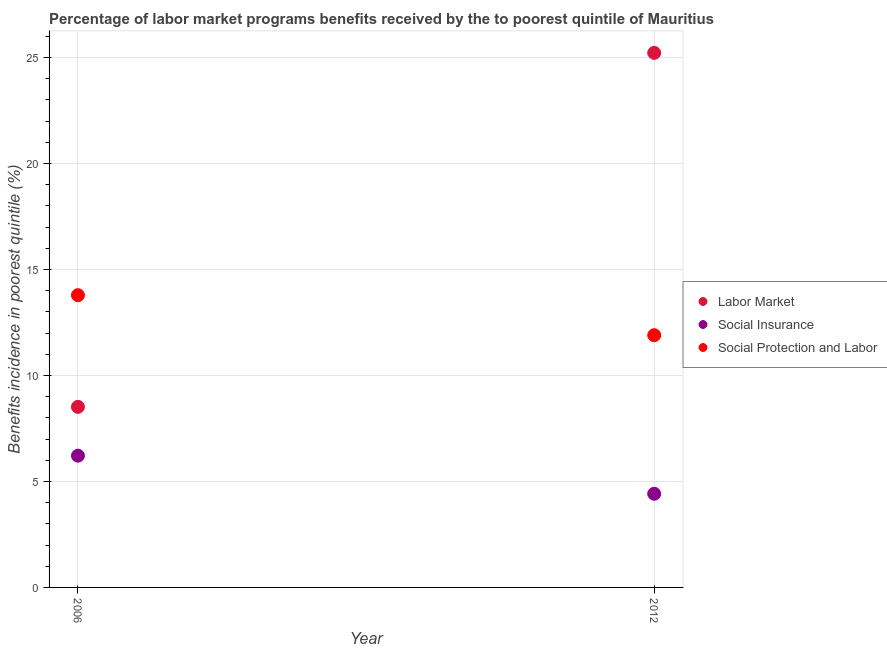What is the percentage of benefits received due to labor market programs in 2006?
Your response must be concise. 8.52. Across all years, what is the maximum percentage of benefits received due to labor market programs?
Ensure brevity in your answer.  25.22. Across all years, what is the minimum percentage of benefits received due to labor market programs?
Ensure brevity in your answer.  8.52. In which year was the percentage of benefits received due to social insurance programs maximum?
Keep it short and to the point. 2006. What is the total percentage of benefits received due to social insurance programs in the graph?
Keep it short and to the point. 10.63. What is the difference between the percentage of benefits received due to social insurance programs in 2006 and that in 2012?
Give a very brief answer. 1.8. What is the difference between the percentage of benefits received due to social protection programs in 2006 and the percentage of benefits received due to social insurance programs in 2012?
Offer a terse response. 9.37. What is the average percentage of benefits received due to social insurance programs per year?
Offer a very short reply. 5.32. In the year 2006, what is the difference between the percentage of benefits received due to social insurance programs and percentage of benefits received due to social protection programs?
Your answer should be very brief. -7.57. What is the ratio of the percentage of benefits received due to social protection programs in 2006 to that in 2012?
Offer a terse response. 1.16. In how many years, is the percentage of benefits received due to social protection programs greater than the average percentage of benefits received due to social protection programs taken over all years?
Provide a short and direct response. 1. Are the values on the major ticks of Y-axis written in scientific E-notation?
Keep it short and to the point. No. Does the graph contain any zero values?
Your answer should be compact. No. Does the graph contain grids?
Offer a very short reply. Yes. How many legend labels are there?
Keep it short and to the point. 3. How are the legend labels stacked?
Provide a short and direct response. Vertical. What is the title of the graph?
Offer a very short reply. Percentage of labor market programs benefits received by the to poorest quintile of Mauritius. What is the label or title of the X-axis?
Provide a short and direct response. Year. What is the label or title of the Y-axis?
Make the answer very short. Benefits incidence in poorest quintile (%). What is the Benefits incidence in poorest quintile (%) in Labor Market in 2006?
Your answer should be compact. 8.52. What is the Benefits incidence in poorest quintile (%) of Social Insurance in 2006?
Keep it short and to the point. 6.22. What is the Benefits incidence in poorest quintile (%) in Social Protection and Labor in 2006?
Provide a short and direct response. 13.79. What is the Benefits incidence in poorest quintile (%) of Labor Market in 2012?
Provide a succinct answer. 25.22. What is the Benefits incidence in poorest quintile (%) of Social Insurance in 2012?
Give a very brief answer. 4.42. What is the Benefits incidence in poorest quintile (%) in Social Protection and Labor in 2012?
Offer a terse response. 11.9. Across all years, what is the maximum Benefits incidence in poorest quintile (%) in Labor Market?
Provide a succinct answer. 25.22. Across all years, what is the maximum Benefits incidence in poorest quintile (%) in Social Insurance?
Keep it short and to the point. 6.22. Across all years, what is the maximum Benefits incidence in poorest quintile (%) of Social Protection and Labor?
Your response must be concise. 13.79. Across all years, what is the minimum Benefits incidence in poorest quintile (%) of Labor Market?
Provide a short and direct response. 8.52. Across all years, what is the minimum Benefits incidence in poorest quintile (%) of Social Insurance?
Ensure brevity in your answer.  4.42. Across all years, what is the minimum Benefits incidence in poorest quintile (%) of Social Protection and Labor?
Your answer should be compact. 11.9. What is the total Benefits incidence in poorest quintile (%) in Labor Market in the graph?
Make the answer very short. 33.73. What is the total Benefits incidence in poorest quintile (%) in Social Insurance in the graph?
Keep it short and to the point. 10.63. What is the total Benefits incidence in poorest quintile (%) of Social Protection and Labor in the graph?
Keep it short and to the point. 25.68. What is the difference between the Benefits incidence in poorest quintile (%) in Labor Market in 2006 and that in 2012?
Keep it short and to the point. -16.7. What is the difference between the Benefits incidence in poorest quintile (%) of Social Insurance in 2006 and that in 2012?
Your answer should be very brief. 1.8. What is the difference between the Benefits incidence in poorest quintile (%) in Social Protection and Labor in 2006 and that in 2012?
Your answer should be compact. 1.89. What is the difference between the Benefits incidence in poorest quintile (%) in Labor Market in 2006 and the Benefits incidence in poorest quintile (%) in Social Insurance in 2012?
Your response must be concise. 4.1. What is the difference between the Benefits incidence in poorest quintile (%) in Labor Market in 2006 and the Benefits incidence in poorest quintile (%) in Social Protection and Labor in 2012?
Keep it short and to the point. -3.38. What is the difference between the Benefits incidence in poorest quintile (%) in Social Insurance in 2006 and the Benefits incidence in poorest quintile (%) in Social Protection and Labor in 2012?
Provide a short and direct response. -5.68. What is the average Benefits incidence in poorest quintile (%) of Labor Market per year?
Your answer should be very brief. 16.87. What is the average Benefits incidence in poorest quintile (%) of Social Insurance per year?
Give a very brief answer. 5.32. What is the average Benefits incidence in poorest quintile (%) in Social Protection and Labor per year?
Offer a very short reply. 12.84. In the year 2006, what is the difference between the Benefits incidence in poorest quintile (%) of Labor Market and Benefits incidence in poorest quintile (%) of Social Insurance?
Give a very brief answer. 2.3. In the year 2006, what is the difference between the Benefits incidence in poorest quintile (%) of Labor Market and Benefits incidence in poorest quintile (%) of Social Protection and Labor?
Make the answer very short. -5.27. In the year 2006, what is the difference between the Benefits incidence in poorest quintile (%) in Social Insurance and Benefits incidence in poorest quintile (%) in Social Protection and Labor?
Ensure brevity in your answer.  -7.57. In the year 2012, what is the difference between the Benefits incidence in poorest quintile (%) of Labor Market and Benefits incidence in poorest quintile (%) of Social Insurance?
Provide a succinct answer. 20.8. In the year 2012, what is the difference between the Benefits incidence in poorest quintile (%) of Labor Market and Benefits incidence in poorest quintile (%) of Social Protection and Labor?
Provide a short and direct response. 13.32. In the year 2012, what is the difference between the Benefits incidence in poorest quintile (%) of Social Insurance and Benefits incidence in poorest quintile (%) of Social Protection and Labor?
Make the answer very short. -7.48. What is the ratio of the Benefits incidence in poorest quintile (%) of Labor Market in 2006 to that in 2012?
Provide a short and direct response. 0.34. What is the ratio of the Benefits incidence in poorest quintile (%) of Social Insurance in 2006 to that in 2012?
Make the answer very short. 1.41. What is the ratio of the Benefits incidence in poorest quintile (%) in Social Protection and Labor in 2006 to that in 2012?
Provide a succinct answer. 1.16. What is the difference between the highest and the second highest Benefits incidence in poorest quintile (%) of Labor Market?
Your response must be concise. 16.7. What is the difference between the highest and the second highest Benefits incidence in poorest quintile (%) of Social Insurance?
Provide a succinct answer. 1.8. What is the difference between the highest and the second highest Benefits incidence in poorest quintile (%) of Social Protection and Labor?
Provide a short and direct response. 1.89. What is the difference between the highest and the lowest Benefits incidence in poorest quintile (%) in Labor Market?
Ensure brevity in your answer.  16.7. What is the difference between the highest and the lowest Benefits incidence in poorest quintile (%) of Social Insurance?
Provide a succinct answer. 1.8. What is the difference between the highest and the lowest Benefits incidence in poorest quintile (%) in Social Protection and Labor?
Ensure brevity in your answer.  1.89. 